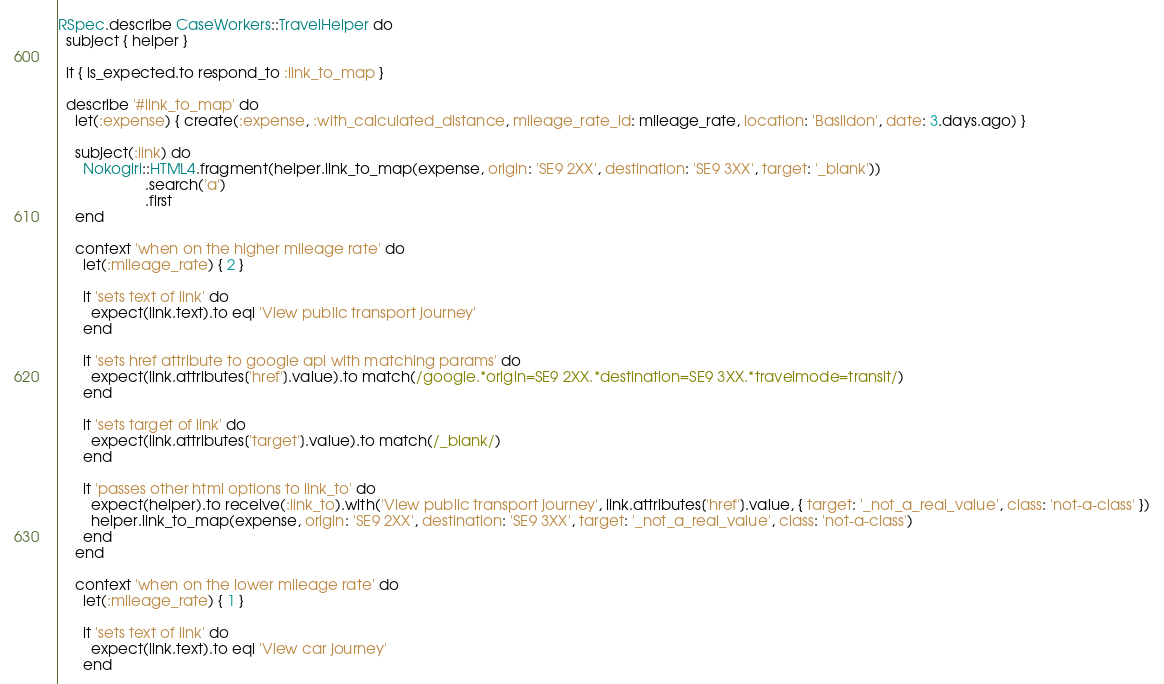Convert code to text. <code><loc_0><loc_0><loc_500><loc_500><_Ruby_>RSpec.describe CaseWorkers::TravelHelper do
  subject { helper }

  it { is_expected.to respond_to :link_to_map }

  describe '#link_to_map' do
    let(:expense) { create(:expense, :with_calculated_distance, mileage_rate_id: mileage_rate, location: 'Basildon', date: 3.days.ago) }

    subject(:link) do
      Nokogiri::HTML4.fragment(helper.link_to_map(expense, origin: 'SE9 2XX', destination: 'SE9 3XX', target: '_blank'))
                     .search('a')
                     .first
    end

    context 'when on the higher mileage rate' do
      let(:mileage_rate) { 2 }

      it 'sets text of link' do
        expect(link.text).to eql 'View public transport journey'
      end

      it 'sets href attribute to google api with matching params' do
        expect(link.attributes['href'].value).to match(/google.*origin=SE9 2XX.*destination=SE9 3XX.*travelmode=transit/)
      end

      it 'sets target of link' do
        expect(link.attributes['target'].value).to match(/_blank/)
      end

      it 'passes other html options to link_to' do
        expect(helper).to receive(:link_to).with('View public transport journey', link.attributes['href'].value, { target: '_not_a_real_value', class: 'not-a-class' })
        helper.link_to_map(expense, origin: 'SE9 2XX', destination: 'SE9 3XX', target: '_not_a_real_value', class: 'not-a-class')
      end
    end

    context 'when on the lower mileage rate' do
      let(:mileage_rate) { 1 }

      it 'sets text of link' do
        expect(link.text).to eql 'View car journey'
      end
</code> 